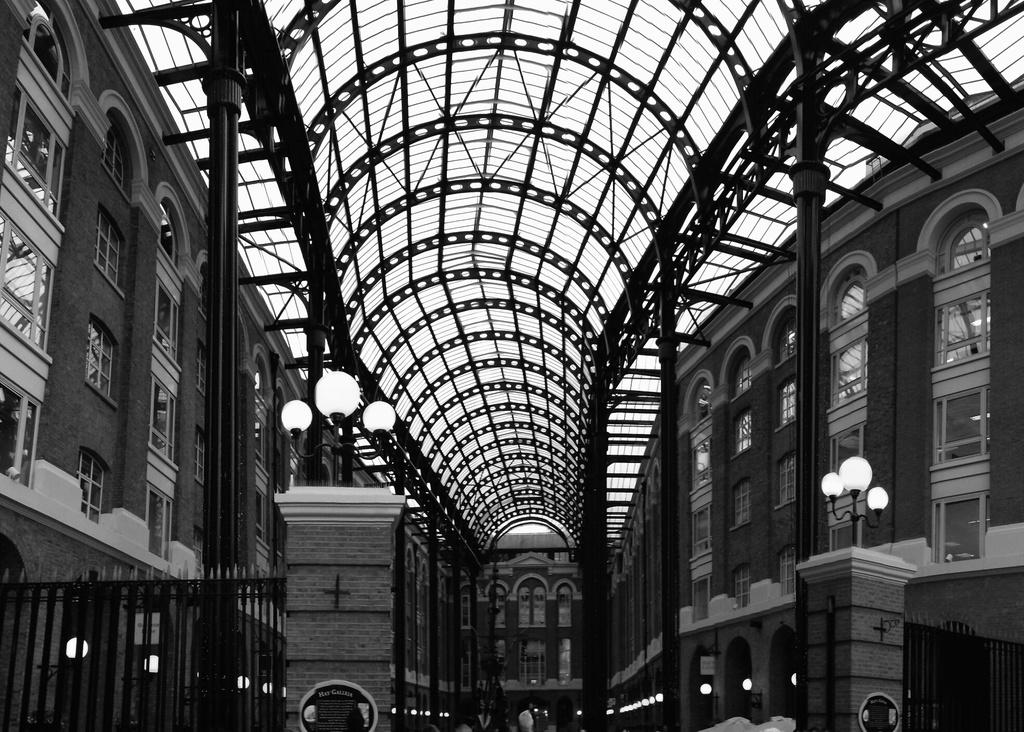What type of image is shown in the picture? The image contains a black and white picture of a building. What architectural features can be seen on the building? The building has windows. What is the purpose of the fence visible in the image? The fence's purpose is not specified in the image, but it could be for security or to mark boundaries. What type of illumination is present in the image? There are lights in the image. What part of the building is visible from the image? The roof of the building is visible. Can you see your sister walking down the street in the image? There is no mention of a street or a sister in the image. Is there a scarecrow standing in front of the building in the image? There is no scarecrow present in the image. 